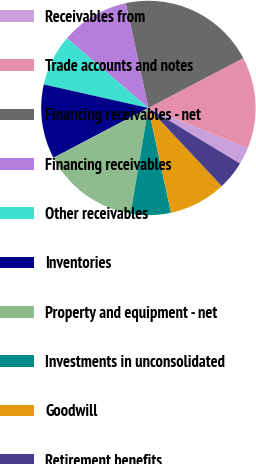Convert chart. <chart><loc_0><loc_0><loc_500><loc_500><pie_chart><fcel>Receivables from<fcel>Trade accounts and notes<fcel>Financing receivables - net<fcel>Financing receivables<fcel>Other receivables<fcel>Inventories<fcel>Property and equipment - net<fcel>Investments in unconsolidated<fcel>Goodwill<fcel>Retirement benefits<nl><fcel>2.59%<fcel>13.79%<fcel>20.69%<fcel>10.34%<fcel>7.76%<fcel>11.21%<fcel>14.65%<fcel>6.04%<fcel>8.62%<fcel>4.31%<nl></chart> 